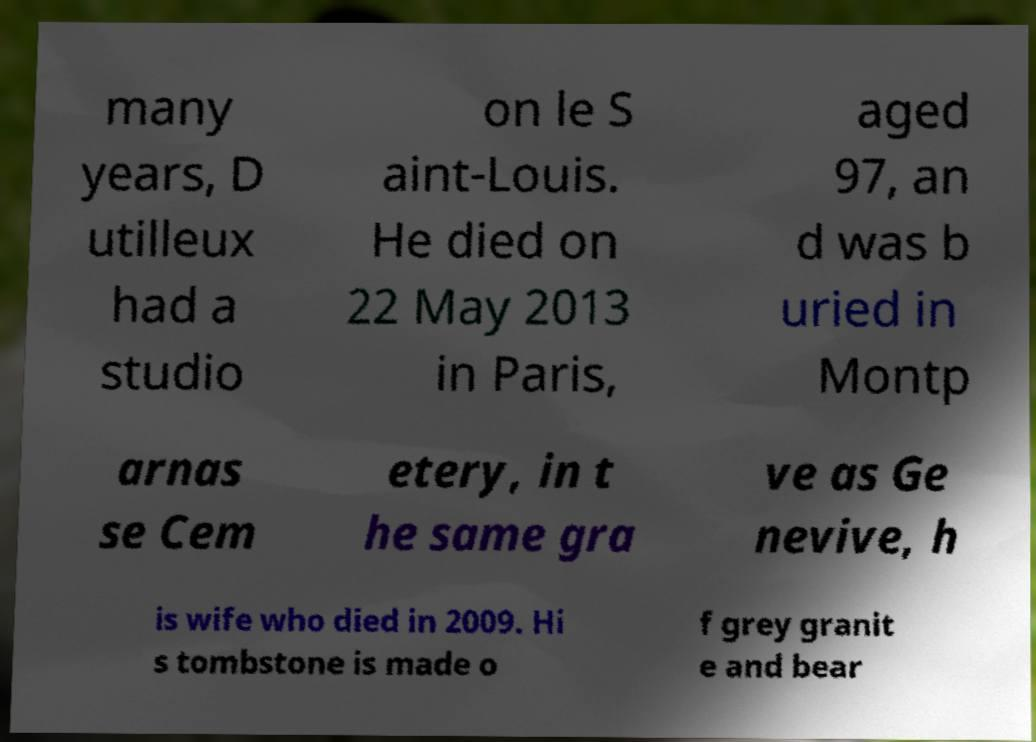Can you read and provide the text displayed in the image?This photo seems to have some interesting text. Can you extract and type it out for me? many years, D utilleux had a studio on le S aint-Louis. He died on 22 May 2013 in Paris, aged 97, an d was b uried in Montp arnas se Cem etery, in t he same gra ve as Ge nevive, h is wife who died in 2009. Hi s tombstone is made o f grey granit e and bear 